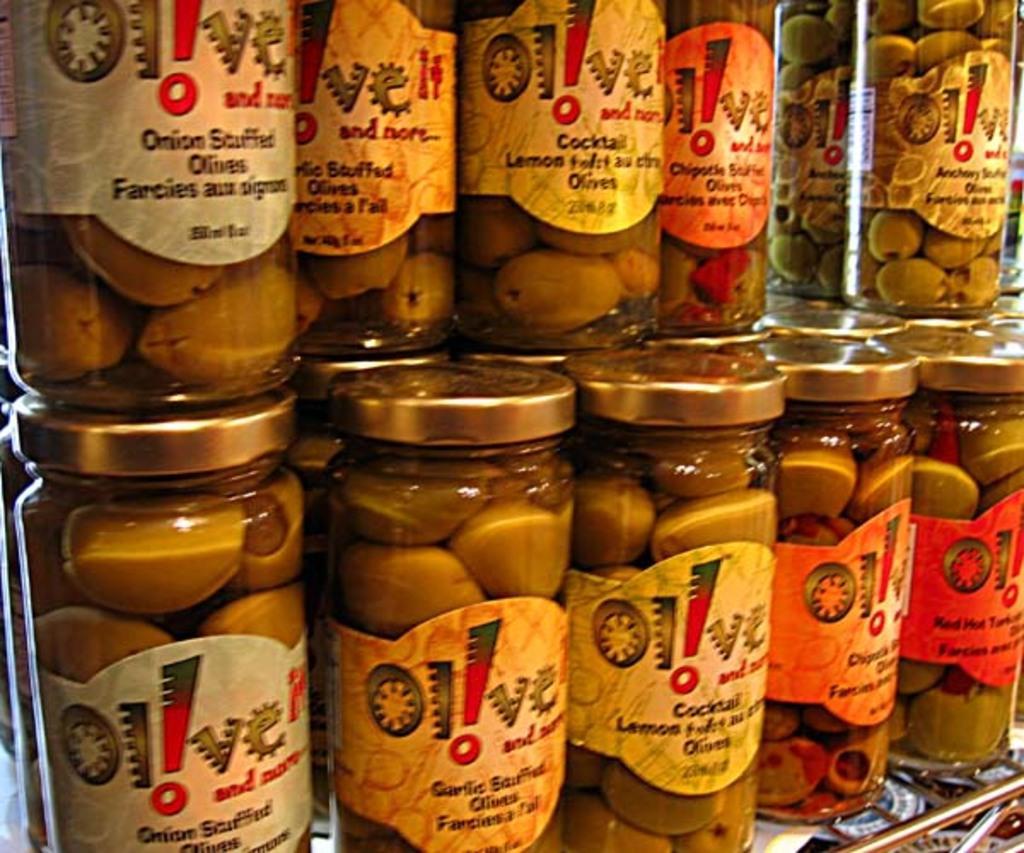Describe this image in one or two sentences. In this image, we can see some bottles, which are placed on the stand, in the bottles, we can see some food items and a paper is attached to a bottle. On the paper, we can see some text. 